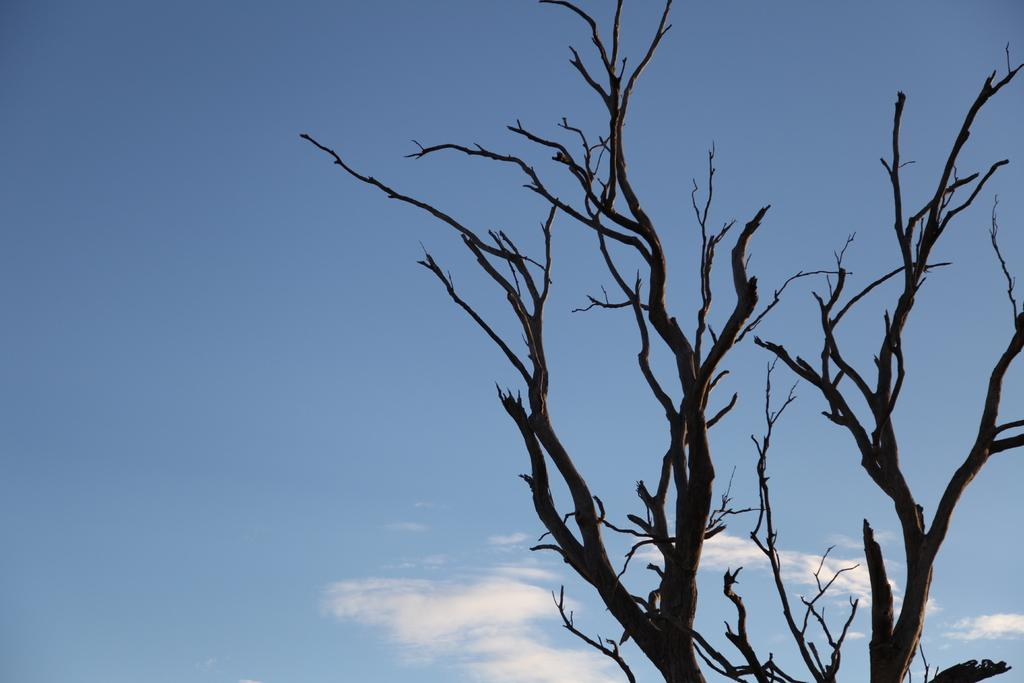What type of natural objects are in the image? There are dried branches of a tree in the image. What part of the environment is visible in the image? The sky is visible in the image. How would you describe the appearance of the sky in the image? The sky looks cloudy in the image. How many times does the person in the image sneeze due to the smell of the pail? There is no person or pail present in the image, so it is not possible to determine how many times they might sneeze. 